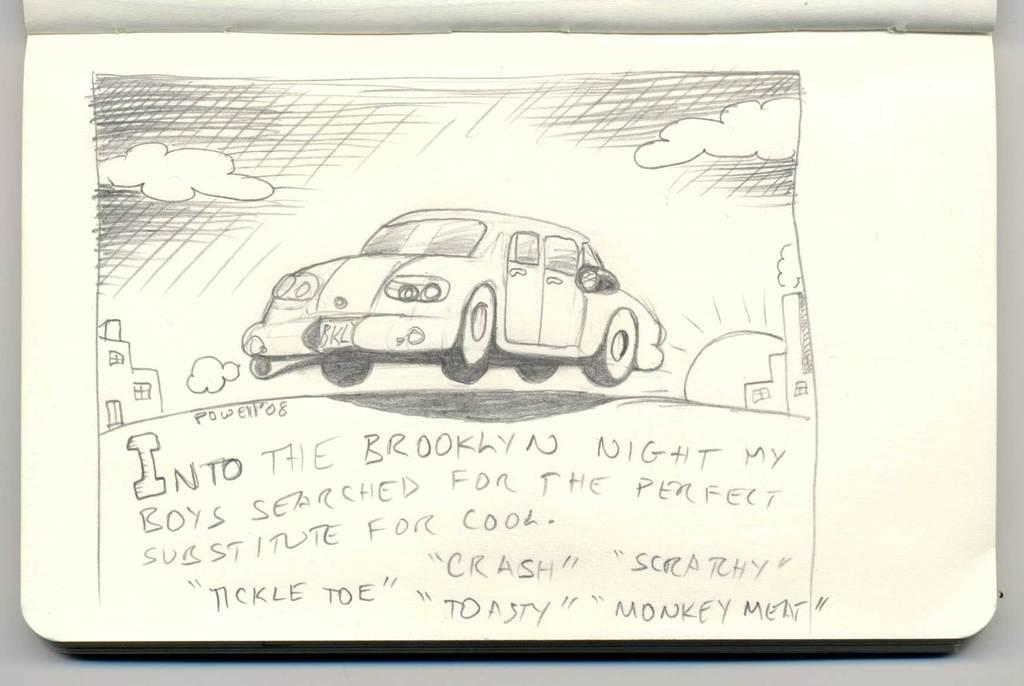What is the main subject of the image? The main subject of the image is a car. What else can be seen in the image besides the car? There are buildings, windows, the sun, clouds, something written on a paper, and the image is a pencil art. What type of club can be seen in the image? There is no club present in the image. What color is the polish used on the car in the image? The image is a pencil art, so there is no actual car or polish applied to it. 